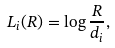Convert formula to latex. <formula><loc_0><loc_0><loc_500><loc_500>L _ { i } ( R ) = \log \frac { R } { d _ { i } } ,</formula> 